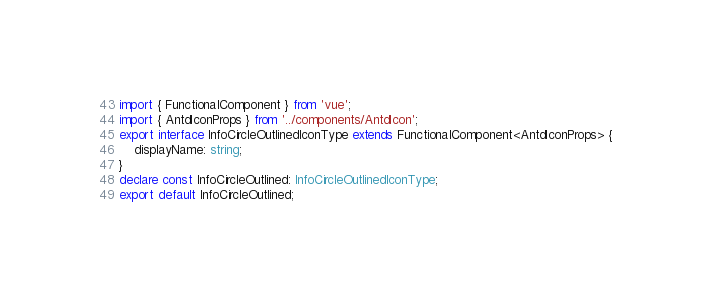<code> <loc_0><loc_0><loc_500><loc_500><_TypeScript_>import { FunctionalComponent } from 'vue';
import { AntdIconProps } from '../components/AntdIcon';
export interface InfoCircleOutlinedIconType extends FunctionalComponent<AntdIconProps> {
    displayName: string;
}
declare const InfoCircleOutlined: InfoCircleOutlinedIconType;
export default InfoCircleOutlined;
</code> 